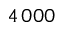Convert formula to latex. <formula><loc_0><loc_0><loc_500><loc_500>4 \, 0 0 0</formula> 